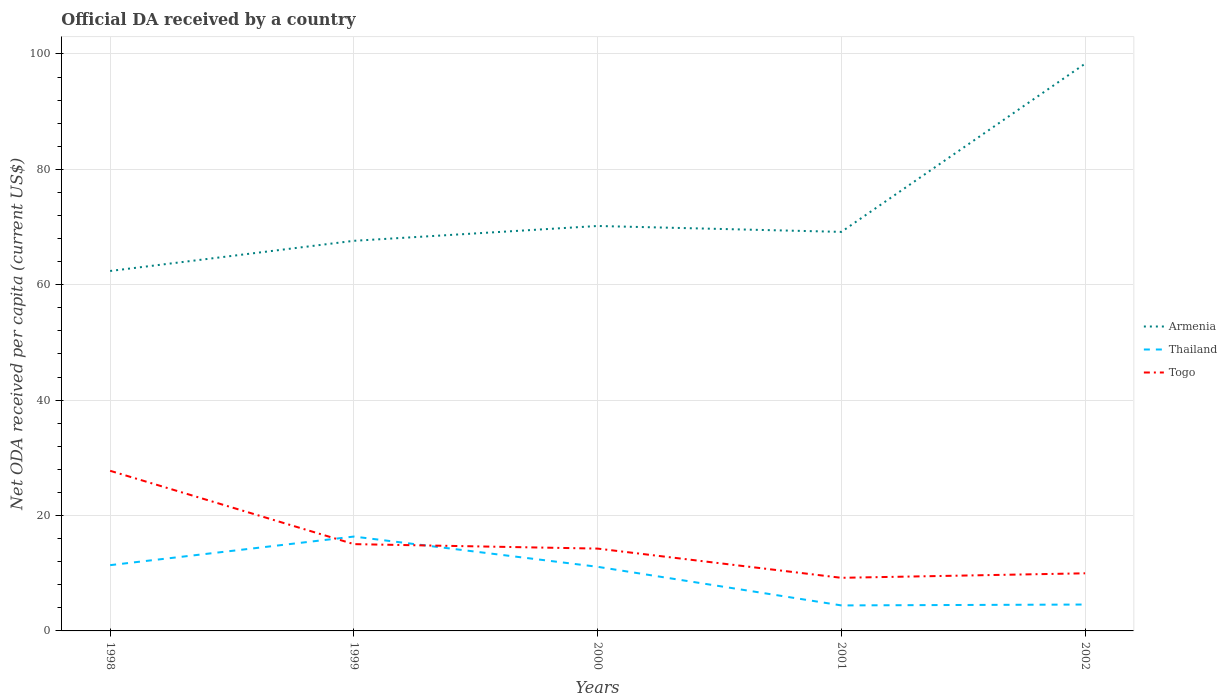Does the line corresponding to Armenia intersect with the line corresponding to Thailand?
Make the answer very short. No. Across all years, what is the maximum ODA received in in Thailand?
Your answer should be compact. 4.42. What is the total ODA received in in Togo in the graph?
Make the answer very short. 18.55. What is the difference between the highest and the second highest ODA received in in Togo?
Offer a terse response. 18.55. Is the ODA received in in Togo strictly greater than the ODA received in in Armenia over the years?
Provide a succinct answer. Yes. How many lines are there?
Keep it short and to the point. 3. Does the graph contain grids?
Your answer should be compact. Yes. Where does the legend appear in the graph?
Provide a short and direct response. Center right. How many legend labels are there?
Offer a very short reply. 3. How are the legend labels stacked?
Provide a short and direct response. Vertical. What is the title of the graph?
Your response must be concise. Official DA received by a country. What is the label or title of the Y-axis?
Offer a terse response. Net ODA received per capita (current US$). What is the Net ODA received per capita (current US$) in Armenia in 1998?
Your answer should be very brief. 62.38. What is the Net ODA received per capita (current US$) of Thailand in 1998?
Keep it short and to the point. 11.4. What is the Net ODA received per capita (current US$) in Togo in 1998?
Offer a terse response. 27.75. What is the Net ODA received per capita (current US$) in Armenia in 1999?
Your response must be concise. 67.61. What is the Net ODA received per capita (current US$) in Thailand in 1999?
Provide a short and direct response. 16.35. What is the Net ODA received per capita (current US$) in Togo in 1999?
Offer a terse response. 15.04. What is the Net ODA received per capita (current US$) in Armenia in 2000?
Make the answer very short. 70.18. What is the Net ODA received per capita (current US$) in Thailand in 2000?
Provide a short and direct response. 11.11. What is the Net ODA received per capita (current US$) of Togo in 2000?
Your answer should be compact. 14.27. What is the Net ODA received per capita (current US$) in Armenia in 2001?
Provide a succinct answer. 69.16. What is the Net ODA received per capita (current US$) of Thailand in 2001?
Your answer should be compact. 4.42. What is the Net ODA received per capita (current US$) in Togo in 2001?
Keep it short and to the point. 9.2. What is the Net ODA received per capita (current US$) in Armenia in 2002?
Keep it short and to the point. 98.31. What is the Net ODA received per capita (current US$) of Thailand in 2002?
Keep it short and to the point. 4.57. What is the Net ODA received per capita (current US$) of Togo in 2002?
Ensure brevity in your answer.  9.99. Across all years, what is the maximum Net ODA received per capita (current US$) of Armenia?
Give a very brief answer. 98.31. Across all years, what is the maximum Net ODA received per capita (current US$) in Thailand?
Give a very brief answer. 16.35. Across all years, what is the maximum Net ODA received per capita (current US$) of Togo?
Give a very brief answer. 27.75. Across all years, what is the minimum Net ODA received per capita (current US$) of Armenia?
Provide a short and direct response. 62.38. Across all years, what is the minimum Net ODA received per capita (current US$) in Thailand?
Ensure brevity in your answer.  4.42. Across all years, what is the minimum Net ODA received per capita (current US$) of Togo?
Your answer should be compact. 9.2. What is the total Net ODA received per capita (current US$) of Armenia in the graph?
Make the answer very short. 367.65. What is the total Net ODA received per capita (current US$) in Thailand in the graph?
Offer a terse response. 47.86. What is the total Net ODA received per capita (current US$) in Togo in the graph?
Provide a succinct answer. 76.25. What is the difference between the Net ODA received per capita (current US$) in Armenia in 1998 and that in 1999?
Make the answer very short. -5.23. What is the difference between the Net ODA received per capita (current US$) in Thailand in 1998 and that in 1999?
Make the answer very short. -4.96. What is the difference between the Net ODA received per capita (current US$) of Togo in 1998 and that in 1999?
Give a very brief answer. 12.71. What is the difference between the Net ODA received per capita (current US$) of Armenia in 1998 and that in 2000?
Make the answer very short. -7.8. What is the difference between the Net ODA received per capita (current US$) in Thailand in 1998 and that in 2000?
Provide a short and direct response. 0.29. What is the difference between the Net ODA received per capita (current US$) of Togo in 1998 and that in 2000?
Give a very brief answer. 13.48. What is the difference between the Net ODA received per capita (current US$) in Armenia in 1998 and that in 2001?
Keep it short and to the point. -6.77. What is the difference between the Net ODA received per capita (current US$) in Thailand in 1998 and that in 2001?
Your answer should be very brief. 6.98. What is the difference between the Net ODA received per capita (current US$) of Togo in 1998 and that in 2001?
Provide a succinct answer. 18.55. What is the difference between the Net ODA received per capita (current US$) of Armenia in 1998 and that in 2002?
Provide a succinct answer. -35.93. What is the difference between the Net ODA received per capita (current US$) of Thailand in 1998 and that in 2002?
Your answer should be compact. 6.82. What is the difference between the Net ODA received per capita (current US$) in Togo in 1998 and that in 2002?
Your response must be concise. 17.77. What is the difference between the Net ODA received per capita (current US$) in Armenia in 1999 and that in 2000?
Offer a terse response. -2.57. What is the difference between the Net ODA received per capita (current US$) of Thailand in 1999 and that in 2000?
Keep it short and to the point. 5.24. What is the difference between the Net ODA received per capita (current US$) of Togo in 1999 and that in 2000?
Your answer should be compact. 0.78. What is the difference between the Net ODA received per capita (current US$) in Armenia in 1999 and that in 2001?
Your answer should be compact. -1.55. What is the difference between the Net ODA received per capita (current US$) of Thailand in 1999 and that in 2001?
Give a very brief answer. 11.93. What is the difference between the Net ODA received per capita (current US$) of Togo in 1999 and that in 2001?
Give a very brief answer. 5.84. What is the difference between the Net ODA received per capita (current US$) of Armenia in 1999 and that in 2002?
Make the answer very short. -30.7. What is the difference between the Net ODA received per capita (current US$) of Thailand in 1999 and that in 2002?
Keep it short and to the point. 11.78. What is the difference between the Net ODA received per capita (current US$) in Togo in 1999 and that in 2002?
Your answer should be very brief. 5.06. What is the difference between the Net ODA received per capita (current US$) of Armenia in 2000 and that in 2001?
Your answer should be compact. 1.02. What is the difference between the Net ODA received per capita (current US$) of Thailand in 2000 and that in 2001?
Provide a short and direct response. 6.69. What is the difference between the Net ODA received per capita (current US$) in Togo in 2000 and that in 2001?
Ensure brevity in your answer.  5.06. What is the difference between the Net ODA received per capita (current US$) in Armenia in 2000 and that in 2002?
Give a very brief answer. -28.13. What is the difference between the Net ODA received per capita (current US$) in Thailand in 2000 and that in 2002?
Offer a terse response. 6.54. What is the difference between the Net ODA received per capita (current US$) in Togo in 2000 and that in 2002?
Your answer should be compact. 4.28. What is the difference between the Net ODA received per capita (current US$) of Armenia in 2001 and that in 2002?
Keep it short and to the point. -29.16. What is the difference between the Net ODA received per capita (current US$) of Thailand in 2001 and that in 2002?
Your response must be concise. -0.15. What is the difference between the Net ODA received per capita (current US$) of Togo in 2001 and that in 2002?
Offer a terse response. -0.78. What is the difference between the Net ODA received per capita (current US$) of Armenia in 1998 and the Net ODA received per capita (current US$) of Thailand in 1999?
Offer a terse response. 46.03. What is the difference between the Net ODA received per capita (current US$) in Armenia in 1998 and the Net ODA received per capita (current US$) in Togo in 1999?
Your answer should be compact. 47.34. What is the difference between the Net ODA received per capita (current US$) in Thailand in 1998 and the Net ODA received per capita (current US$) in Togo in 1999?
Make the answer very short. -3.65. What is the difference between the Net ODA received per capita (current US$) of Armenia in 1998 and the Net ODA received per capita (current US$) of Thailand in 2000?
Your response must be concise. 51.27. What is the difference between the Net ODA received per capita (current US$) in Armenia in 1998 and the Net ODA received per capita (current US$) in Togo in 2000?
Ensure brevity in your answer.  48.12. What is the difference between the Net ODA received per capita (current US$) in Thailand in 1998 and the Net ODA received per capita (current US$) in Togo in 2000?
Your answer should be compact. -2.87. What is the difference between the Net ODA received per capita (current US$) in Armenia in 1998 and the Net ODA received per capita (current US$) in Thailand in 2001?
Your answer should be very brief. 57.96. What is the difference between the Net ODA received per capita (current US$) in Armenia in 1998 and the Net ODA received per capita (current US$) in Togo in 2001?
Provide a short and direct response. 53.18. What is the difference between the Net ODA received per capita (current US$) in Thailand in 1998 and the Net ODA received per capita (current US$) in Togo in 2001?
Your answer should be compact. 2.19. What is the difference between the Net ODA received per capita (current US$) in Armenia in 1998 and the Net ODA received per capita (current US$) in Thailand in 2002?
Provide a short and direct response. 57.81. What is the difference between the Net ODA received per capita (current US$) in Armenia in 1998 and the Net ODA received per capita (current US$) in Togo in 2002?
Ensure brevity in your answer.  52.4. What is the difference between the Net ODA received per capita (current US$) in Thailand in 1998 and the Net ODA received per capita (current US$) in Togo in 2002?
Ensure brevity in your answer.  1.41. What is the difference between the Net ODA received per capita (current US$) in Armenia in 1999 and the Net ODA received per capita (current US$) in Thailand in 2000?
Your response must be concise. 56.5. What is the difference between the Net ODA received per capita (current US$) of Armenia in 1999 and the Net ODA received per capita (current US$) of Togo in 2000?
Offer a terse response. 53.34. What is the difference between the Net ODA received per capita (current US$) in Thailand in 1999 and the Net ODA received per capita (current US$) in Togo in 2000?
Your answer should be very brief. 2.09. What is the difference between the Net ODA received per capita (current US$) of Armenia in 1999 and the Net ODA received per capita (current US$) of Thailand in 2001?
Provide a short and direct response. 63.19. What is the difference between the Net ODA received per capita (current US$) of Armenia in 1999 and the Net ODA received per capita (current US$) of Togo in 2001?
Provide a short and direct response. 58.41. What is the difference between the Net ODA received per capita (current US$) of Thailand in 1999 and the Net ODA received per capita (current US$) of Togo in 2001?
Offer a very short reply. 7.15. What is the difference between the Net ODA received per capita (current US$) of Armenia in 1999 and the Net ODA received per capita (current US$) of Thailand in 2002?
Provide a short and direct response. 63.04. What is the difference between the Net ODA received per capita (current US$) in Armenia in 1999 and the Net ODA received per capita (current US$) in Togo in 2002?
Offer a terse response. 57.63. What is the difference between the Net ODA received per capita (current US$) of Thailand in 1999 and the Net ODA received per capita (current US$) of Togo in 2002?
Make the answer very short. 6.37. What is the difference between the Net ODA received per capita (current US$) in Armenia in 2000 and the Net ODA received per capita (current US$) in Thailand in 2001?
Offer a terse response. 65.76. What is the difference between the Net ODA received per capita (current US$) in Armenia in 2000 and the Net ODA received per capita (current US$) in Togo in 2001?
Make the answer very short. 60.98. What is the difference between the Net ODA received per capita (current US$) in Thailand in 2000 and the Net ODA received per capita (current US$) in Togo in 2001?
Your answer should be very brief. 1.91. What is the difference between the Net ODA received per capita (current US$) of Armenia in 2000 and the Net ODA received per capita (current US$) of Thailand in 2002?
Ensure brevity in your answer.  65.61. What is the difference between the Net ODA received per capita (current US$) in Armenia in 2000 and the Net ODA received per capita (current US$) in Togo in 2002?
Offer a terse response. 60.2. What is the difference between the Net ODA received per capita (current US$) of Thailand in 2000 and the Net ODA received per capita (current US$) of Togo in 2002?
Offer a terse response. 1.13. What is the difference between the Net ODA received per capita (current US$) in Armenia in 2001 and the Net ODA received per capita (current US$) in Thailand in 2002?
Keep it short and to the point. 64.59. What is the difference between the Net ODA received per capita (current US$) in Armenia in 2001 and the Net ODA received per capita (current US$) in Togo in 2002?
Your answer should be compact. 59.17. What is the difference between the Net ODA received per capita (current US$) of Thailand in 2001 and the Net ODA received per capita (current US$) of Togo in 2002?
Make the answer very short. -5.56. What is the average Net ODA received per capita (current US$) in Armenia per year?
Keep it short and to the point. 73.53. What is the average Net ODA received per capita (current US$) in Thailand per year?
Make the answer very short. 9.57. What is the average Net ODA received per capita (current US$) in Togo per year?
Your response must be concise. 15.25. In the year 1998, what is the difference between the Net ODA received per capita (current US$) of Armenia and Net ODA received per capita (current US$) of Thailand?
Your response must be concise. 50.99. In the year 1998, what is the difference between the Net ODA received per capita (current US$) of Armenia and Net ODA received per capita (current US$) of Togo?
Your response must be concise. 34.63. In the year 1998, what is the difference between the Net ODA received per capita (current US$) in Thailand and Net ODA received per capita (current US$) in Togo?
Provide a short and direct response. -16.35. In the year 1999, what is the difference between the Net ODA received per capita (current US$) in Armenia and Net ODA received per capita (current US$) in Thailand?
Ensure brevity in your answer.  51.26. In the year 1999, what is the difference between the Net ODA received per capita (current US$) of Armenia and Net ODA received per capita (current US$) of Togo?
Your answer should be very brief. 52.57. In the year 1999, what is the difference between the Net ODA received per capita (current US$) in Thailand and Net ODA received per capita (current US$) in Togo?
Your response must be concise. 1.31. In the year 2000, what is the difference between the Net ODA received per capita (current US$) in Armenia and Net ODA received per capita (current US$) in Thailand?
Provide a short and direct response. 59.07. In the year 2000, what is the difference between the Net ODA received per capita (current US$) in Armenia and Net ODA received per capita (current US$) in Togo?
Give a very brief answer. 55.92. In the year 2000, what is the difference between the Net ODA received per capita (current US$) of Thailand and Net ODA received per capita (current US$) of Togo?
Offer a very short reply. -3.16. In the year 2001, what is the difference between the Net ODA received per capita (current US$) in Armenia and Net ODA received per capita (current US$) in Thailand?
Offer a very short reply. 64.74. In the year 2001, what is the difference between the Net ODA received per capita (current US$) of Armenia and Net ODA received per capita (current US$) of Togo?
Offer a very short reply. 59.95. In the year 2001, what is the difference between the Net ODA received per capita (current US$) of Thailand and Net ODA received per capita (current US$) of Togo?
Your response must be concise. -4.78. In the year 2002, what is the difference between the Net ODA received per capita (current US$) of Armenia and Net ODA received per capita (current US$) of Thailand?
Your answer should be very brief. 93.74. In the year 2002, what is the difference between the Net ODA received per capita (current US$) of Armenia and Net ODA received per capita (current US$) of Togo?
Your answer should be compact. 88.33. In the year 2002, what is the difference between the Net ODA received per capita (current US$) in Thailand and Net ODA received per capita (current US$) in Togo?
Your answer should be compact. -5.41. What is the ratio of the Net ODA received per capita (current US$) of Armenia in 1998 to that in 1999?
Keep it short and to the point. 0.92. What is the ratio of the Net ODA received per capita (current US$) of Thailand in 1998 to that in 1999?
Make the answer very short. 0.7. What is the ratio of the Net ODA received per capita (current US$) in Togo in 1998 to that in 1999?
Offer a terse response. 1.84. What is the ratio of the Net ODA received per capita (current US$) of Armenia in 1998 to that in 2000?
Give a very brief answer. 0.89. What is the ratio of the Net ODA received per capita (current US$) of Thailand in 1998 to that in 2000?
Your response must be concise. 1.03. What is the ratio of the Net ODA received per capita (current US$) of Togo in 1998 to that in 2000?
Keep it short and to the point. 1.95. What is the ratio of the Net ODA received per capita (current US$) in Armenia in 1998 to that in 2001?
Provide a succinct answer. 0.9. What is the ratio of the Net ODA received per capita (current US$) of Thailand in 1998 to that in 2001?
Provide a short and direct response. 2.58. What is the ratio of the Net ODA received per capita (current US$) of Togo in 1998 to that in 2001?
Ensure brevity in your answer.  3.02. What is the ratio of the Net ODA received per capita (current US$) in Armenia in 1998 to that in 2002?
Make the answer very short. 0.63. What is the ratio of the Net ODA received per capita (current US$) in Thailand in 1998 to that in 2002?
Keep it short and to the point. 2.49. What is the ratio of the Net ODA received per capita (current US$) in Togo in 1998 to that in 2002?
Your answer should be very brief. 2.78. What is the ratio of the Net ODA received per capita (current US$) of Armenia in 1999 to that in 2000?
Make the answer very short. 0.96. What is the ratio of the Net ODA received per capita (current US$) of Thailand in 1999 to that in 2000?
Your response must be concise. 1.47. What is the ratio of the Net ODA received per capita (current US$) in Togo in 1999 to that in 2000?
Your answer should be very brief. 1.05. What is the ratio of the Net ODA received per capita (current US$) of Armenia in 1999 to that in 2001?
Your answer should be compact. 0.98. What is the ratio of the Net ODA received per capita (current US$) in Thailand in 1999 to that in 2001?
Give a very brief answer. 3.7. What is the ratio of the Net ODA received per capita (current US$) in Togo in 1999 to that in 2001?
Your response must be concise. 1.63. What is the ratio of the Net ODA received per capita (current US$) in Armenia in 1999 to that in 2002?
Offer a terse response. 0.69. What is the ratio of the Net ODA received per capita (current US$) of Thailand in 1999 to that in 2002?
Give a very brief answer. 3.58. What is the ratio of the Net ODA received per capita (current US$) of Togo in 1999 to that in 2002?
Offer a very short reply. 1.51. What is the ratio of the Net ODA received per capita (current US$) in Armenia in 2000 to that in 2001?
Your answer should be very brief. 1.01. What is the ratio of the Net ODA received per capita (current US$) in Thailand in 2000 to that in 2001?
Provide a succinct answer. 2.51. What is the ratio of the Net ODA received per capita (current US$) of Togo in 2000 to that in 2001?
Offer a terse response. 1.55. What is the ratio of the Net ODA received per capita (current US$) of Armenia in 2000 to that in 2002?
Ensure brevity in your answer.  0.71. What is the ratio of the Net ODA received per capita (current US$) in Thailand in 2000 to that in 2002?
Provide a short and direct response. 2.43. What is the ratio of the Net ODA received per capita (current US$) of Togo in 2000 to that in 2002?
Your answer should be very brief. 1.43. What is the ratio of the Net ODA received per capita (current US$) in Armenia in 2001 to that in 2002?
Offer a terse response. 0.7. What is the ratio of the Net ODA received per capita (current US$) in Thailand in 2001 to that in 2002?
Ensure brevity in your answer.  0.97. What is the ratio of the Net ODA received per capita (current US$) in Togo in 2001 to that in 2002?
Offer a very short reply. 0.92. What is the difference between the highest and the second highest Net ODA received per capita (current US$) in Armenia?
Offer a very short reply. 28.13. What is the difference between the highest and the second highest Net ODA received per capita (current US$) in Thailand?
Give a very brief answer. 4.96. What is the difference between the highest and the second highest Net ODA received per capita (current US$) of Togo?
Give a very brief answer. 12.71. What is the difference between the highest and the lowest Net ODA received per capita (current US$) in Armenia?
Give a very brief answer. 35.93. What is the difference between the highest and the lowest Net ODA received per capita (current US$) of Thailand?
Offer a very short reply. 11.93. What is the difference between the highest and the lowest Net ODA received per capita (current US$) of Togo?
Give a very brief answer. 18.55. 